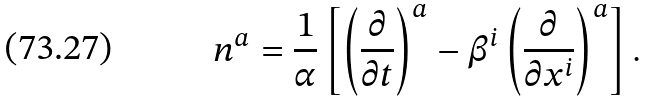Convert formula to latex. <formula><loc_0><loc_0><loc_500><loc_500>n ^ { a } = \frac { 1 } { \alpha } \left [ \left ( \frac { \partial } { \partial t } \right ) ^ { a } - \beta ^ { i } \left ( \frac { \partial } { \partial x ^ { i } } \right ) ^ { a } \right ] .</formula> 